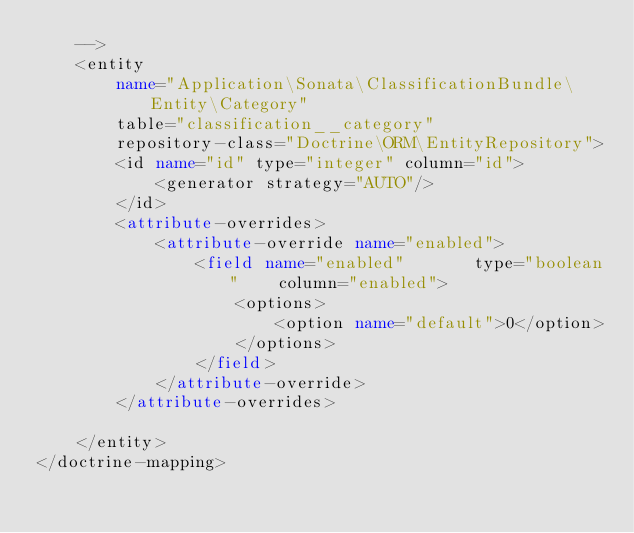Convert code to text. <code><loc_0><loc_0><loc_500><loc_500><_XML_>    -->
    <entity
        name="Application\Sonata\ClassificationBundle\Entity\Category"
        table="classification__category"
        repository-class="Doctrine\ORM\EntityRepository">
        <id name="id" type="integer" column="id">
            <generator strategy="AUTO"/>
        </id>
        <attribute-overrides>
            <attribute-override name="enabled">
                <field name="enabled"       type="boolean"    column="enabled">
                    <options>
                        <option name="default">0</option>
                    </options>
                </field>
            </attribute-override>
        </attribute-overrides>

    </entity>
</doctrine-mapping></code> 